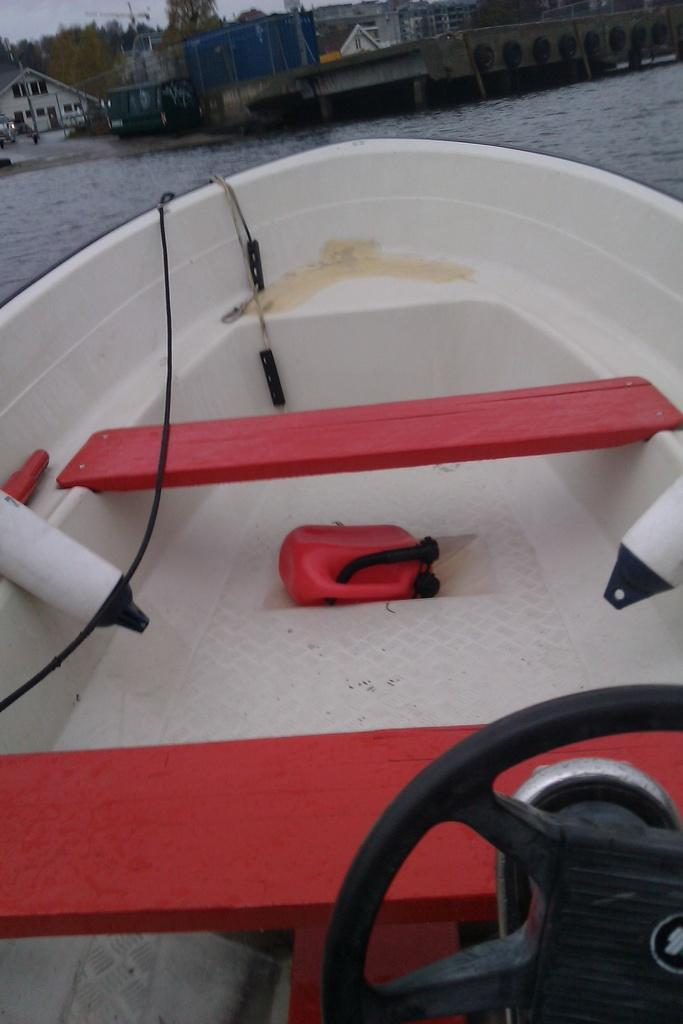What is the main subject of the image? The main subject of the image is a boat. Where is the boat located? The boat is on water. What other structures or objects can be seen in the image? There are buildings, trees, poles, and tires visible in the image. What is visible in the background of the image? The sky is visible in the image. What type of pencil can be seen floating in the water next to the boat? There is no pencil visible in the image; it only features a boat, water, buildings, trees, poles, tires, and the sky. Can you recite a verse that is written on the boat in the image? There is no verse or writing visible on the boat in the image. 